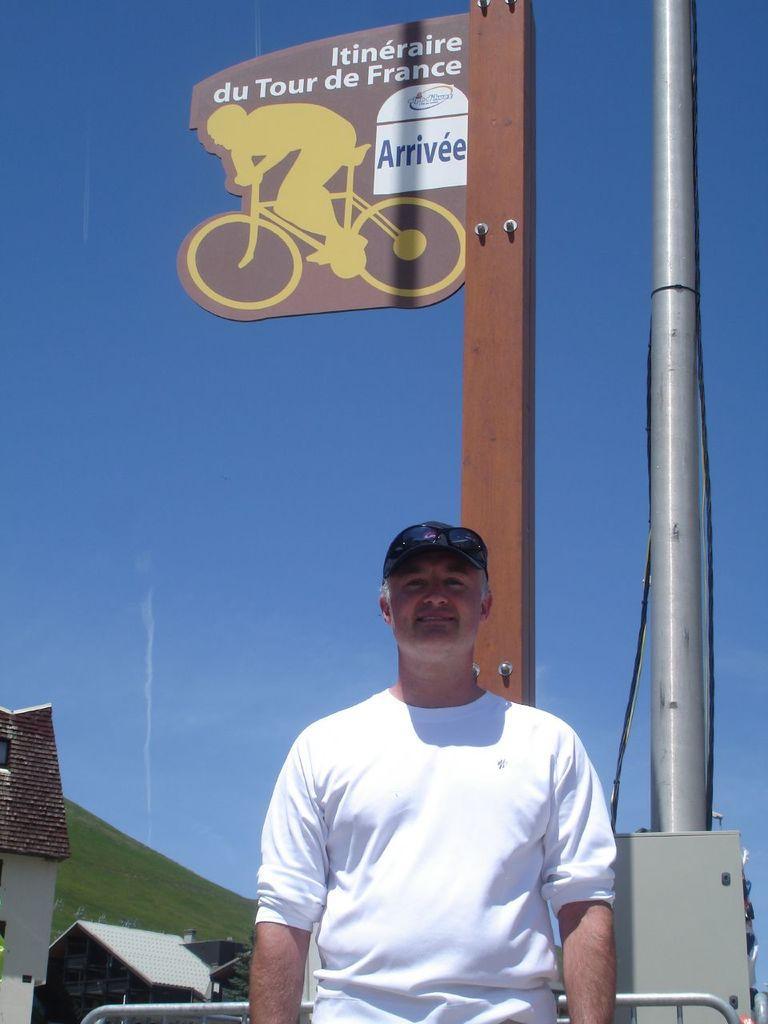Describe this image in one or two sentences. In this picture there is a man in the center of the image and there is a sign pole in the center of the image, there are houses in the bottom left side of the image. 